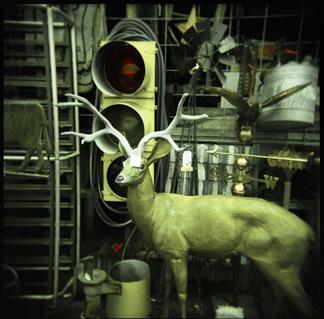Are these items for sale?
Keep it brief. Yes. Where is there an arrow?
Be succinct. Above deer. Is the stag real or not real?
Quick response, please. Not real. 